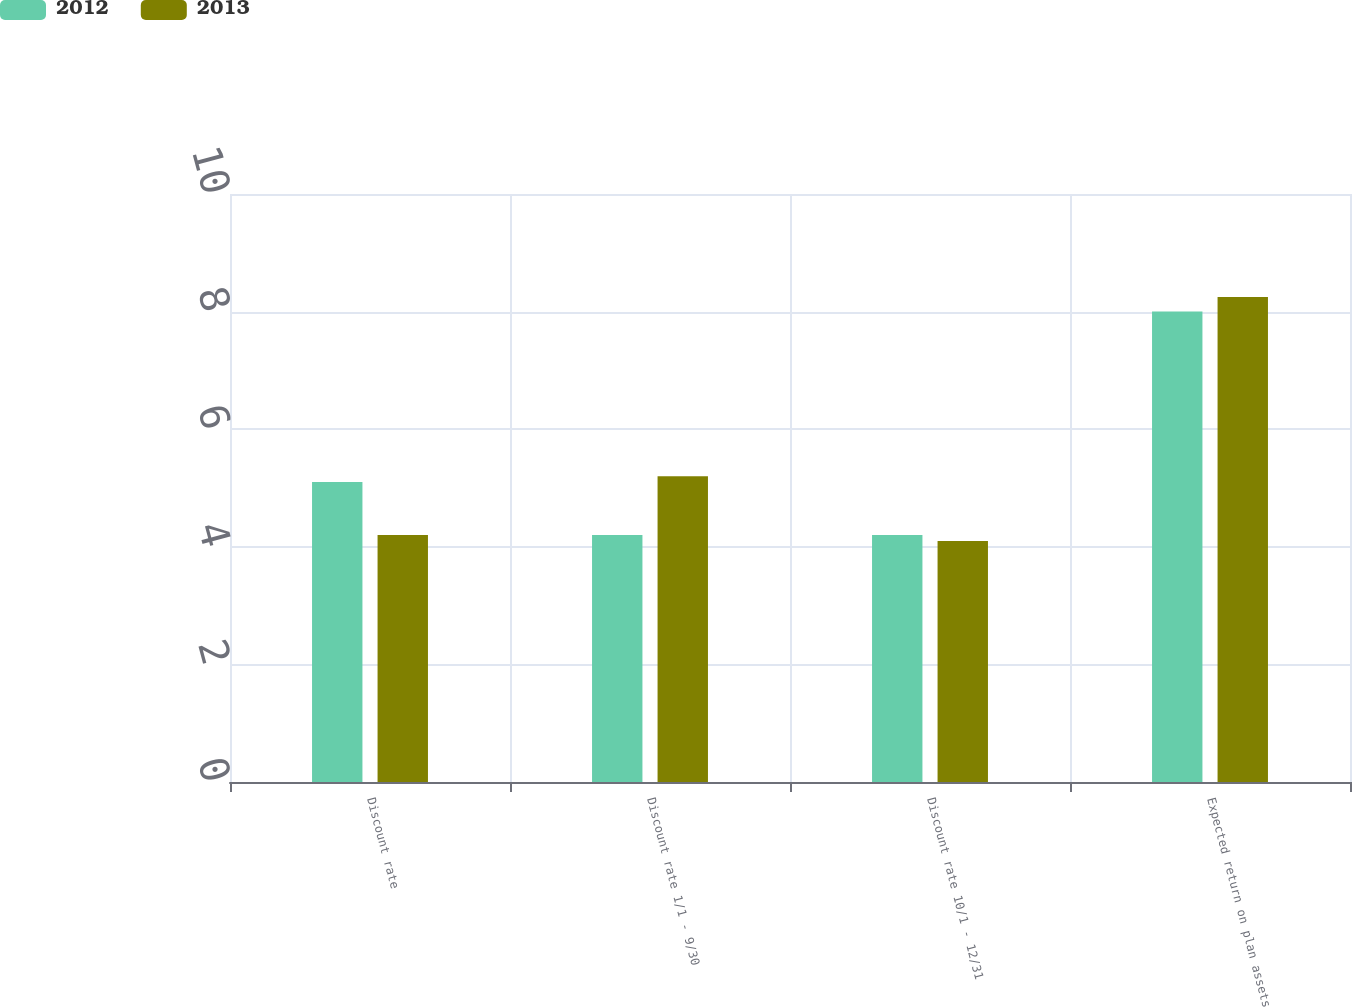Convert chart. <chart><loc_0><loc_0><loc_500><loc_500><stacked_bar_chart><ecel><fcel>Discount rate<fcel>Discount rate 1/1 - 9/30<fcel>Discount rate 10/1 - 12/31<fcel>Expected return on plan assets<nl><fcel>2012<fcel>5.1<fcel>4.2<fcel>4.2<fcel>8<nl><fcel>2013<fcel>4.2<fcel>5.2<fcel>4.1<fcel>8.25<nl></chart> 